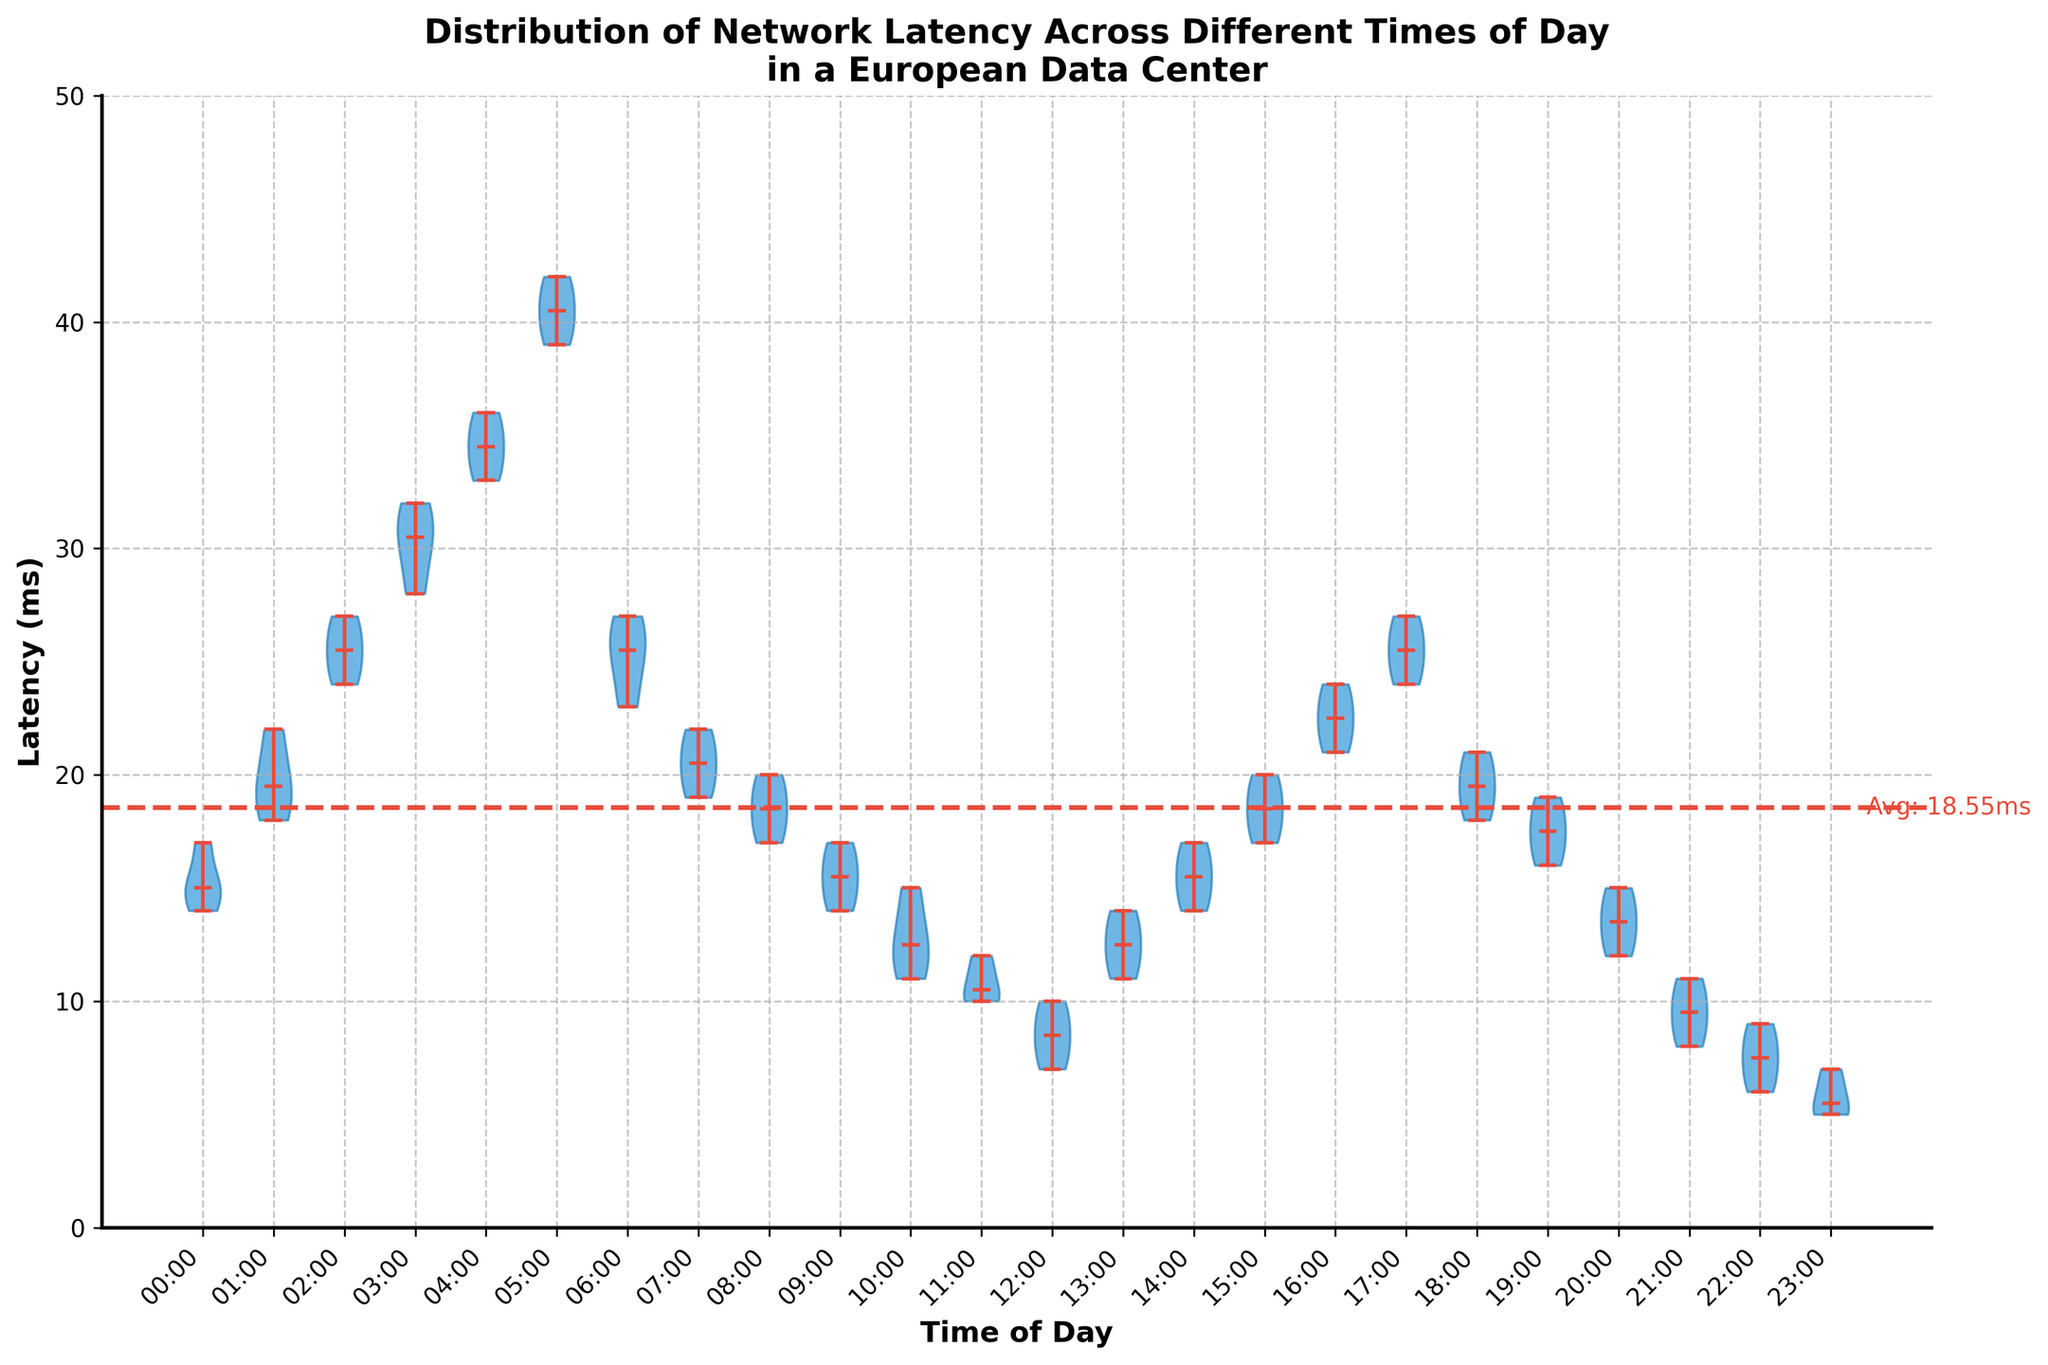What is the title of the figure? The title of the figure is indicated at the top. It reads "Distribution of Network Latency Across Different Times of Day in a European Data Center".
Answer: Distribution of Network Latency Across Different Times of Day in a European Data Center What data is represented on the y-axis? The y-axis shows the network latency in milliseconds (ms). This is indicated by the label on the y-axis which reads "Latency (ms)".
Answer: Latency (ms) Which time of day has the lowest median latency? The median latency is represented by a horizontal line within each violin. The time of day with the lowest median latency is 23:00, as its median line is the lowest on the y-axis.
Answer: 23:00 What is the average latency across all times of day? A horizontal dashed line indicates the average latency on the y-axis. The text label next to this line reads "Avg: 18.58ms".
Answer: 18.58 ms During which hours does the latency exceed 30 ms for the highest latency values? The violins that extend past the 30 ms mark represent the hours between 3:00 and 5:00. Observations exceed 30ms for these hours.
Answer: 3:00 to 5:00 What is the range of latencies at 12:00? The range can be seen by noting the highest and lowest points of the violin for 12:00. It extends from 7 ms to 10 ms.
Answer: 7 ms to 10 ms How does the latency at 4:00 compare to that at 10:00? The median latency at 4:00 is significantly higher than at 10:00. The violin for 4:00 takes up much more vertical space and has a higher position on the y-axis compared to the violin for 10:00.
Answer: Higher at 4:00 than at 10:00 Which hours show a decrease in median latency compared to the previous hour? By observing the position of the median lines, the hours where the median line drops from the previous hour include 6:00 (from 5:00), 10:00 (from 9:00), 12:00 (from 11:00), 18:00 (from 17:00), and 23:00 (from 22:00).
Answer: 6:00, 10:00, 12:00, 18:00, 23:00 What’s the most notable trend visible from the chart? From the chart, it is evident that latency tends to be higher during early morning hours (3:00 to 5:00) and decreases sharply as the day progresses, reaching the lowest median values late at night (23:00).
Answer: Higher in early morning, lower late night 